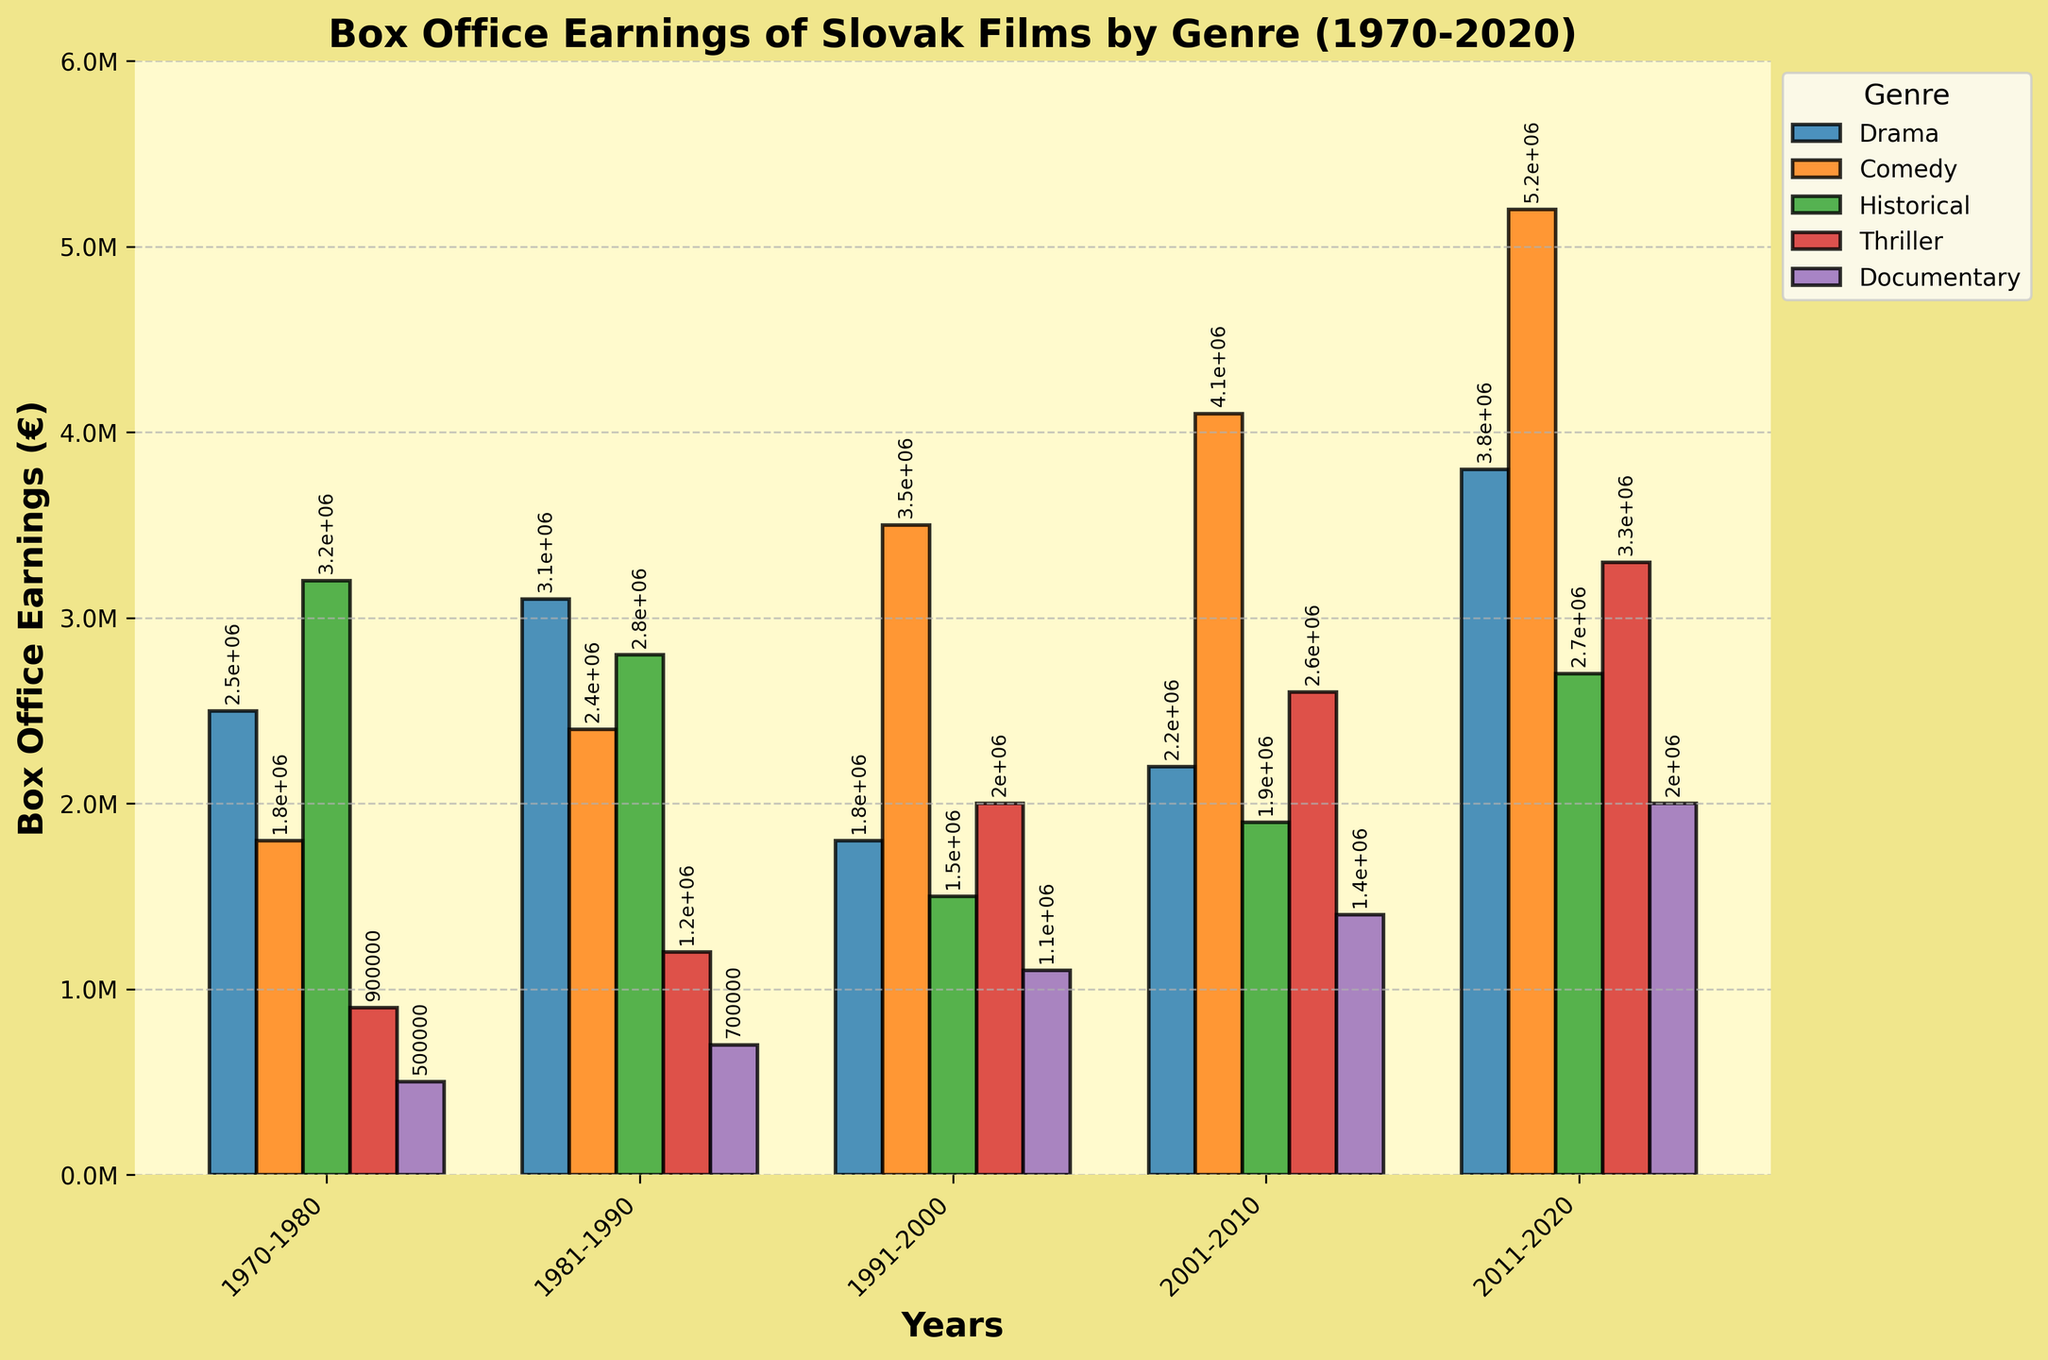Which genre had the highest box office earnings in the 2011-2020 period? Look at the bar corresponding to the 2011-2020 period and compare the heights of the bars for each genre. The tallest bar represents the genre with the highest earnings.
Answer: Comedy How did the box office earnings for drama in the 1991-2000 period compare to the 2001-2010 period? Find the bars corresponding to 'Drama' for the periods 1991-2000 and 2001-2010. The height of the bar in 1991-2000 is lower than in 2001-2010.
Answer: Increased What was the total box office earnings for documentaries from 1970 to 2020? Sum the heights of the bars corresponding to 'Documentary' from all the periods. Sum is 500000 + 700000 + 1100000 + 1400000 + 2000000.
Answer: 5.2 million Which genre showed the most significant increase in earnings between 1970-1980 and 2011-2020? Calculate the difference in heights between the bars for each genre in the periods 2011-2020 and 1970-1980. The highest difference indicates the most significant increase. Comedy increased from 1800000 to 5200000.
Answer: Comedy Among the genres, which one had the lowest aggregate box office earnings over the entire period? Sum the heights of the bars for each genre across all the periods. The lowest sum indicates the genre with the lowest aggregate earnings. Thriller: 900000 + 1200000 + 2000000 + 2600000 + 3300000 = 10.1 million.
Answer: Thriller In which period did the historical genre see the highest box office earnings? Identify the tallest bar among those representing the 'Historical' genre across all periods. The tallest bar is in the 1970-1980 period.
Answer: 1970-1980 What is the average box office earnings of comedy films across all periods? Sum the heights of the bars for the 'Comedy' genre and divide by the number of periods. Sum is 1800000 + 2400000 + 3500000 + 4100000 + 5200000 = 17000000. Average is 17000000 / 5.
Answer: 3.4 million By how much did the thriller genre's box office earnings change from the 1991-2000 period to the 2001-2010 period? Subtract the earnings in 1991-2000 from the earnings in 2001-2010. 2600000 - 2000000 = 600000.
Answer: Increased by 600,000 What is the trend in box office earnings for historical films over the periods? Observe the change in height of the bars for 'Historical' genre across the periods. The earnings peaked in the 1970-1980 period, then fluctuate but never exceed the initial period's earnings.
Answer: Decreasing trend with fluctuations Which genres had greater earnings in the 1981-1990 period compared to the previous period (1970-1980)? Compare the bar heights of each genre between 1970-1980 and 1981-1990. If the bar is taller in 1981-1990, the genre had greater earnings. Drama, Comedy, and Thriller had increased earnings.
Answer: Drama, Comedy, Thriller 